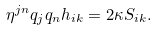Convert formula to latex. <formula><loc_0><loc_0><loc_500><loc_500>\eta ^ { j n } q _ { j } q _ { n } h _ { i k } = 2 \kappa S _ { i k } .</formula> 